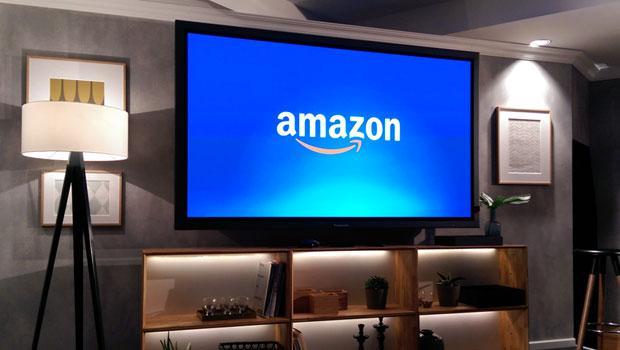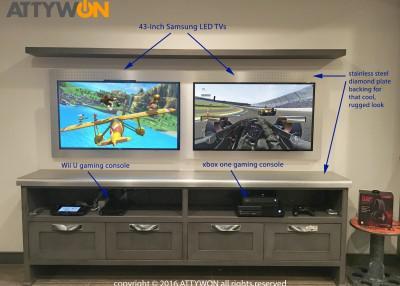The first image is the image on the left, the second image is the image on the right. Considering the images on both sides, is "There are no more than 4 standalone monitors." valid? Answer yes or no. No. The first image is the image on the left, the second image is the image on the right. For the images displayed, is the sentence "Here we have more than four monitors/televisions." factually correct? Answer yes or no. No. 